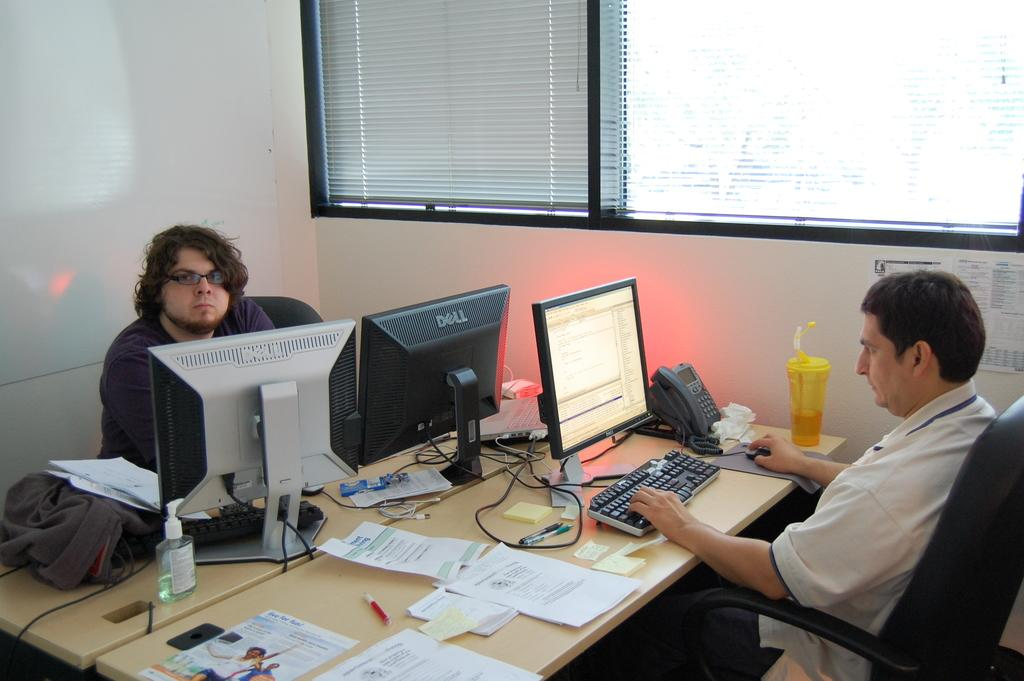<image>
Write a terse but informative summary of the picture. A man works on a Dell computer at a desk across from another man. 